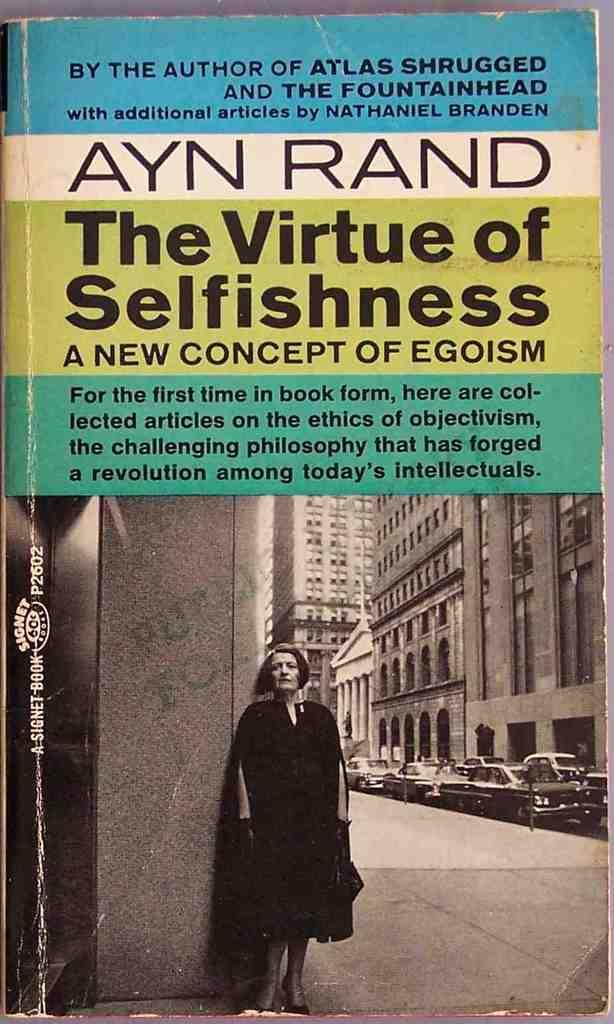Provide a one-sentence caption for the provided image. Front cover of the book, The Virtue of Selfishness. 